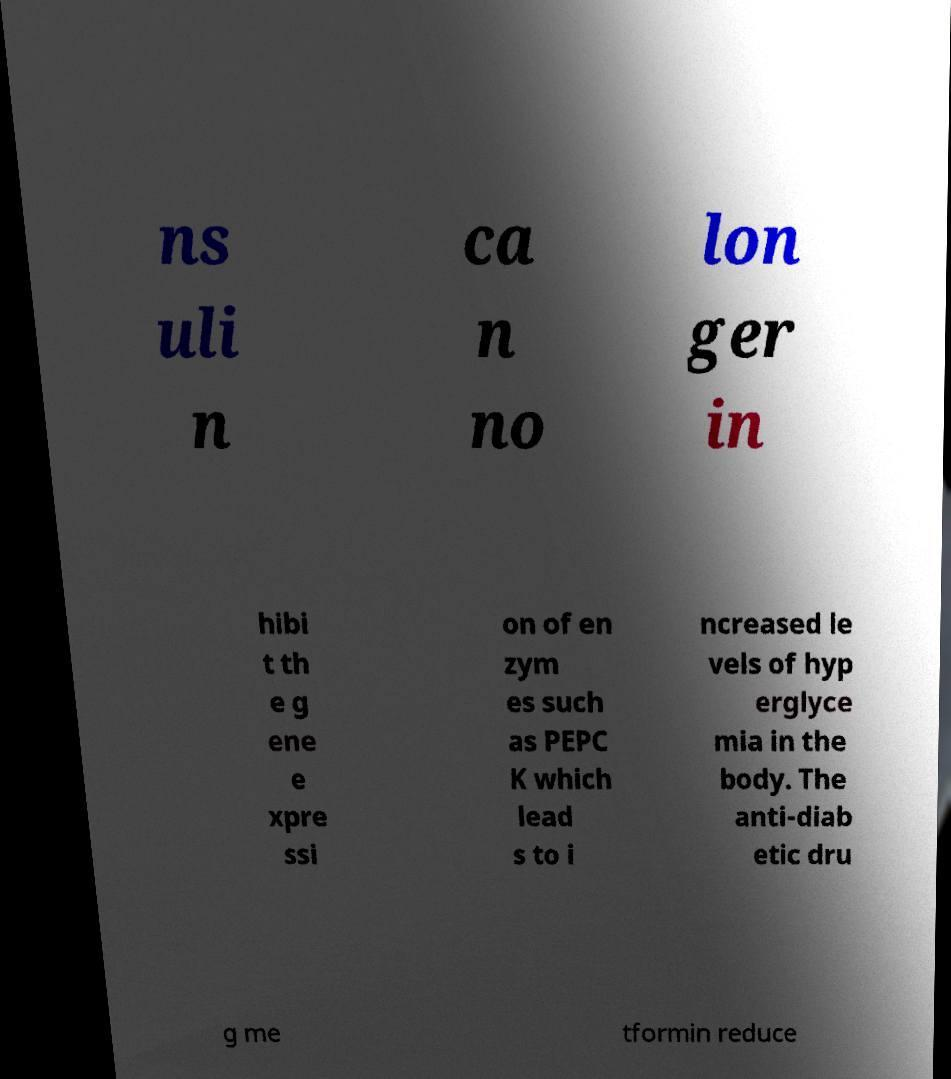There's text embedded in this image that I need extracted. Can you transcribe it verbatim? ns uli n ca n no lon ger in hibi t th e g ene e xpre ssi on of en zym es such as PEPC K which lead s to i ncreased le vels of hyp erglyce mia in the body. The anti-diab etic dru g me tformin reduce 